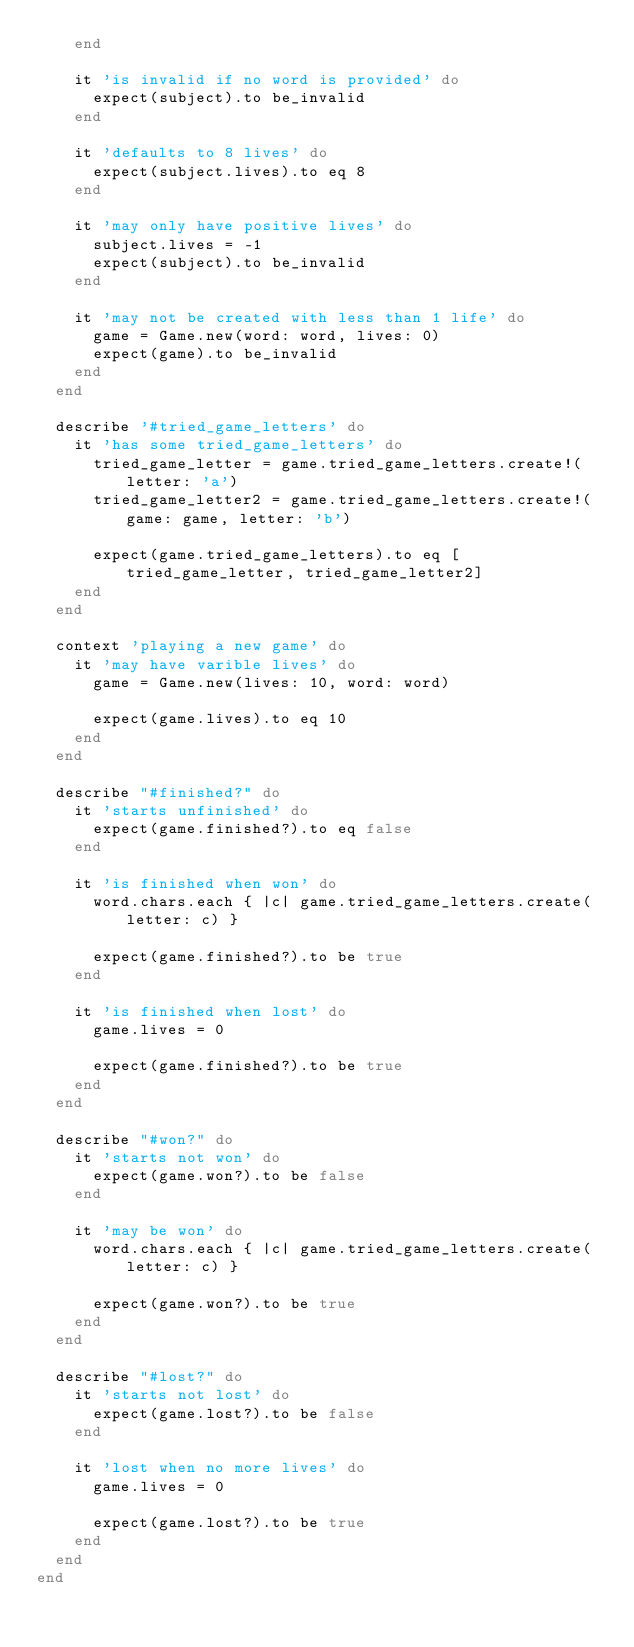<code> <loc_0><loc_0><loc_500><loc_500><_Ruby_>    end

    it 'is invalid if no word is provided' do
      expect(subject).to be_invalid
    end

    it 'defaults to 8 lives' do
      expect(subject.lives).to eq 8
    end

    it 'may only have positive lives' do
      subject.lives = -1
      expect(subject).to be_invalid
    end

    it 'may not be created with less than 1 life' do
      game = Game.new(word: word, lives: 0)
      expect(game).to be_invalid
    end
  end

  describe '#tried_game_letters' do
    it 'has some tried_game_letters' do
      tried_game_letter = game.tried_game_letters.create!(letter: 'a')
      tried_game_letter2 = game.tried_game_letters.create!(game: game, letter: 'b')

      expect(game.tried_game_letters).to eq [tried_game_letter, tried_game_letter2]
    end
  end

  context 'playing a new game' do
    it 'may have varible lives' do
      game = Game.new(lives: 10, word: word)

      expect(game.lives).to eq 10
    end
  end

  describe "#finished?" do
    it 'starts unfinished' do
      expect(game.finished?).to eq false
    end

    it 'is finished when won' do
      word.chars.each { |c| game.tried_game_letters.create(letter: c) }

      expect(game.finished?).to be true
    end

    it 'is finished when lost' do
      game.lives = 0

      expect(game.finished?).to be true 
    end
  end

  describe "#won?" do
    it 'starts not won' do
      expect(game.won?).to be false
    end

    it 'may be won' do
      word.chars.each { |c| game.tried_game_letters.create(letter: c) }

      expect(game.won?).to be true
    end
  end

  describe "#lost?" do
    it 'starts not lost' do
      expect(game.lost?).to be false
    end

    it 'lost when no more lives' do
      game.lives = 0

      expect(game.lost?).to be true
    end
  end
end
</code> 